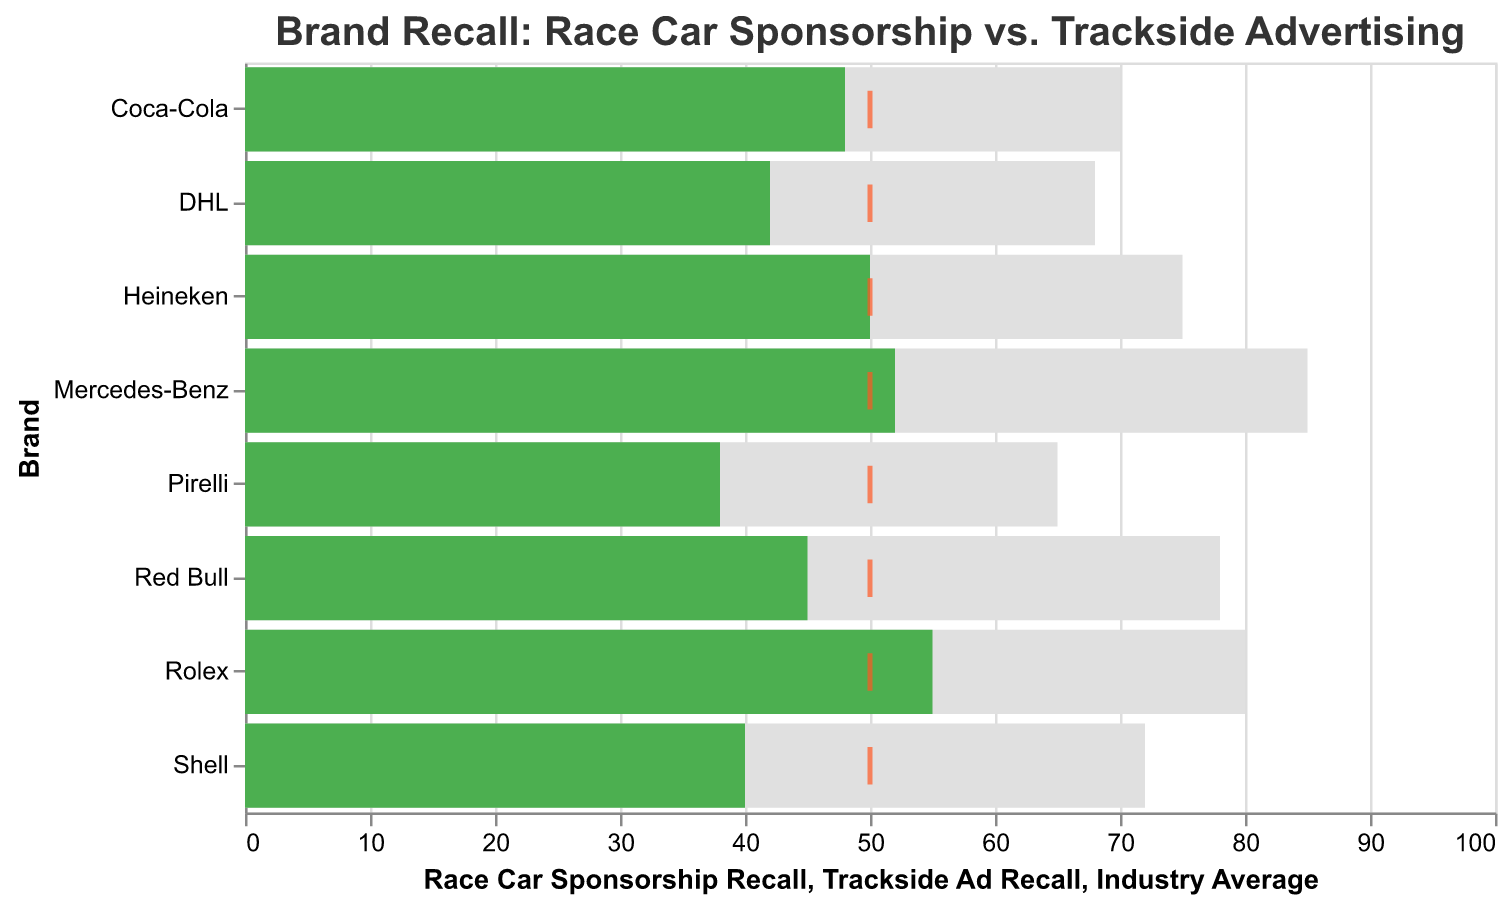What is the title of the plot? The title is typically located at the top of the plot, summarizing its content or purpose.
Answer: Brand Recall: Race Car Sponsorship vs. Trackside Advertising Which brand has the highest Race Car Sponsorship Recall? By examining the lengths of the bars corresponding to each brand under "Race Car Sponsorship Recall," we can see that the brand with the longest bar is Mercedes-Benz.
Answer: Mercedes-Benz How many brands have a higher recall percentage for Race Car Sponsorship compared to Trackside Ad Recall? By comparing the lengths of the bars for "Race Car Sponsorship Recall" and "Trackside Ad Recall" for each brand, we look for cases where the bar for Race Car Sponsorship exceeds that for Trackside Ad Recall.
Answer: 8 brands Which brand's Trackside Ad Recall is closest to the Industry Average? By comparing the positions of the small ticks (representing Industry Average) with the bars representing Trackside Ad Recall, we find that Heineken's bar is closest to the tick at the 50% mark.
Answer: Heineken What is the difference in Race Car Sponsorship Recall between Red Bull and Coca-Cola? Locate the bars for Race Car Sponsorship for the two brands. Red Bull has 78%, and Coca-Cola has 70%. The difference is 78 - 70.
Answer: 8 Which brand has the smallest gap between Race Car Sponsorship Recall and Trackside Ad Recall? Calculate the gap for each brand by subtracting Trackside Ad Recall from Race Car Sponsorship Recall and find the smallest value among them. Heineken has the smallest gap (75 - 50 = 25).
Answer: Heineken Does any brand's Trackside Ad Recall exceed the Industry Average? If so, which brands? Compare the lengths of the "Trackside Ad Recall" bars with the position of the Industry Average (50%). Trackside Ad Recall exceeds the Industry Average for Mercedes-Benz (52), Coca-Cola (48), and Rolex (55).
Answer: Mercedes-Benz, Rolex Sort brands by Race Car Sponsorship Recall in descending order. Arrange the brands based on the heights of the bars for Race Car Sponsorship Recall from the tallest to the shortest.
Answer: Mercedes-Benz, Rolex, Red Bull, Heineken, Shell, Coca-Cola, DHL, Pirelli 